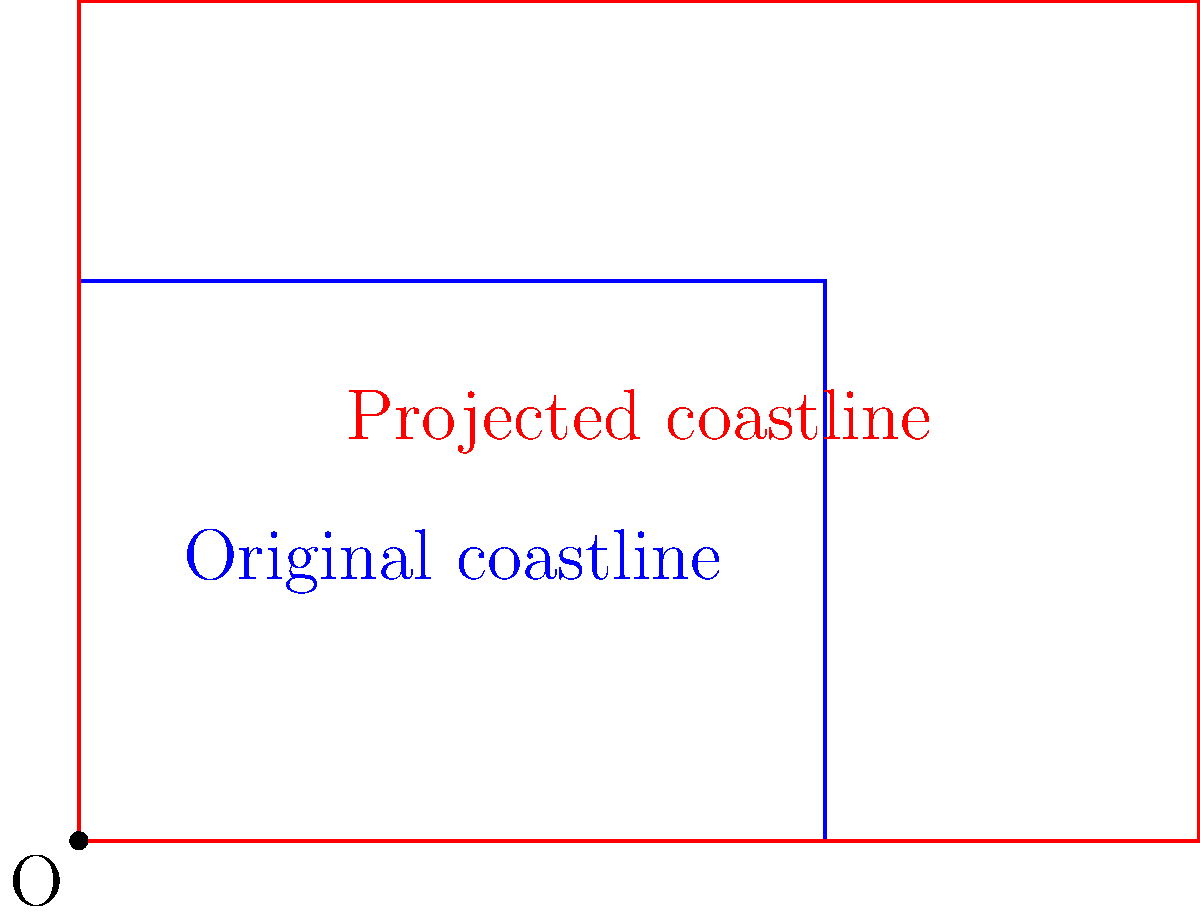A coastal city is planning for future sea level rise. The original coastline is represented by a rectangle with width 4 km and height 3 km. If sea levels are projected to rise, causing the coastline to expand by a scale factor of 1.5 from the origin (0,0), what will be the new area affected by sea level rise? Let's approach this step-by-step:

1) First, we need to calculate the original area:
   Area = width × height
   Area = 4 km × 3 km = 12 km²

2) When we dilate a shape by a scale factor, the new area is equal to the square of the scale factor times the original area.

3) The scale factor given is 1.5, so we need to calculate (1.5)²:
   (1.5)² = 1.5 × 1.5 = 2.25

4) Now, we can calculate the new area:
   New Area = (scale factor)² × Original Area
   New Area = 2.25 × 12 km²
   New Area = 27 km²

5) To find the additional area affected, we subtract the original area from the new area:
   Additional Area = New Area - Original Area
   Additional Area = 27 km² - 12 km² = 15 km²

Therefore, an additional 15 km² will be affected by the sea level rise.
Answer: 15 km² 